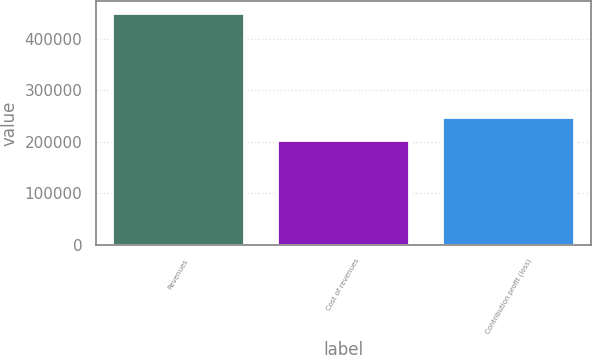Convert chart. <chart><loc_0><loc_0><loc_500><loc_500><bar_chart><fcel>Revenues<fcel>Cost of revenues<fcel>Contribution profit (loss)<nl><fcel>450497<fcel>202525<fcel>247972<nl></chart> 